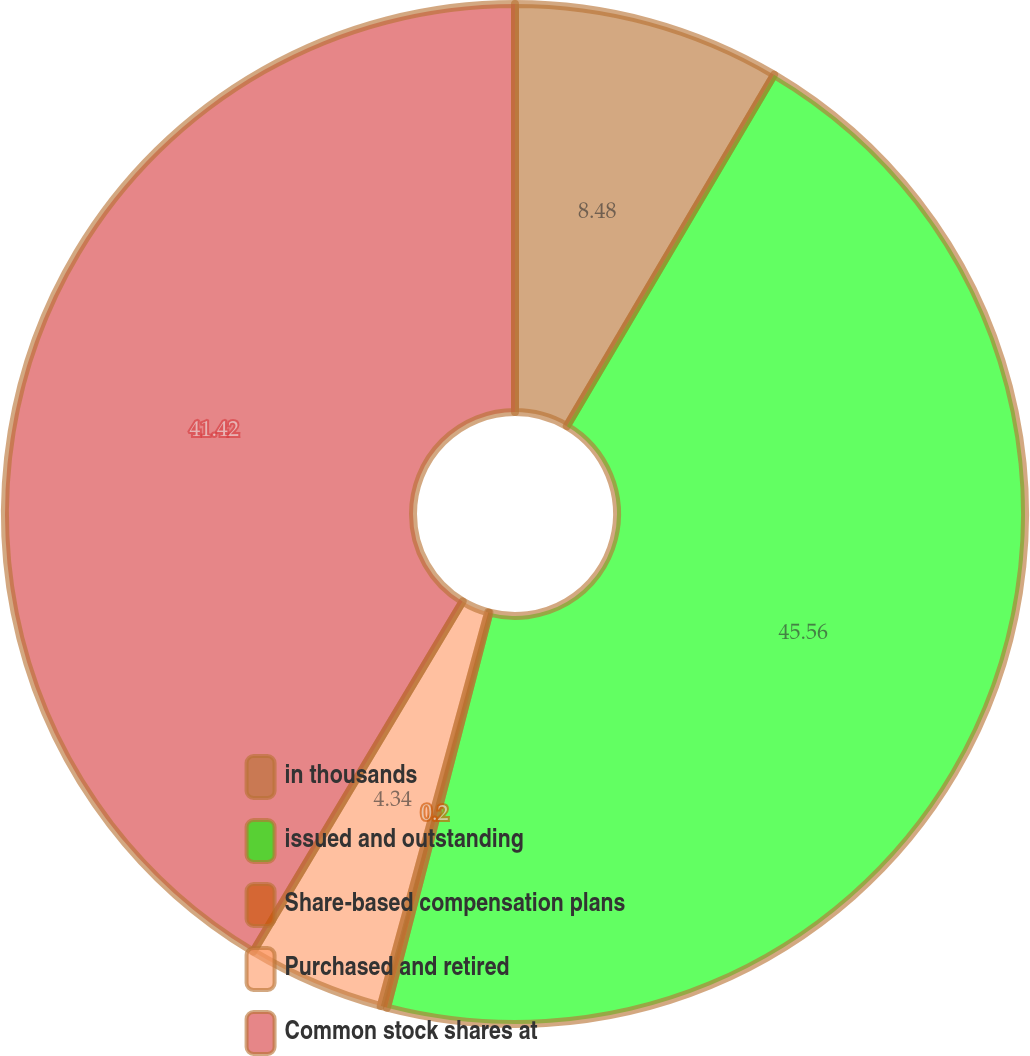Convert chart to OTSL. <chart><loc_0><loc_0><loc_500><loc_500><pie_chart><fcel>in thousands<fcel>issued and outstanding<fcel>Share-based compensation plans<fcel>Purchased and retired<fcel>Common stock shares at<nl><fcel>8.48%<fcel>45.56%<fcel>0.2%<fcel>4.34%<fcel>41.42%<nl></chart> 